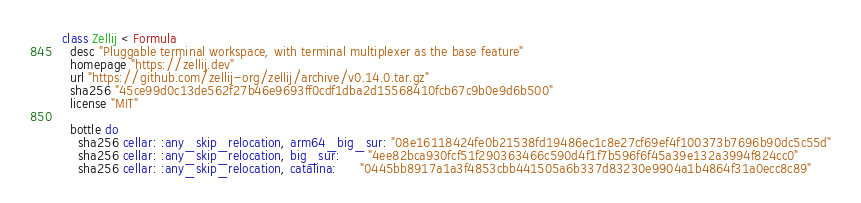Convert code to text. <code><loc_0><loc_0><loc_500><loc_500><_Ruby_>class Zellij < Formula
  desc "Pluggable terminal workspace, with terminal multiplexer as the base feature"
  homepage "https://zellij.dev"
  url "https://github.com/zellij-org/zellij/archive/v0.14.0.tar.gz"
  sha256 "45ce99d0c13de562f27b46e9693ff0cdf1dba2d15568410fcb67c9b0e9d6b500"
  license "MIT"

  bottle do
    sha256 cellar: :any_skip_relocation, arm64_big_sur: "08e16118424fe0b21538fd19486ec1c8e27cf69ef4f100373b7696b90dc5c55d"
    sha256 cellar: :any_skip_relocation, big_sur:       "4ee82bca930fcf51f290363466c590d4f1f7b596f6f45a39e132a3994f824cc0"
    sha256 cellar: :any_skip_relocation, catalina:      "0445bb8917a1a3f4853cbb441505a6b337d83230e9904a1b4864f31a0ecc8c89"</code> 